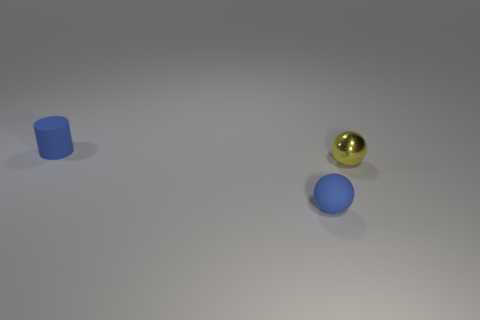Add 1 spheres. How many objects exist? 4 Subtract all spheres. How many objects are left? 1 Add 2 blue matte cylinders. How many blue matte cylinders are left? 3 Add 1 small blue balls. How many small blue balls exist? 2 Subtract 0 yellow cubes. How many objects are left? 3 Subtract all gray spheres. Subtract all yellow cubes. How many spheres are left? 2 Subtract all tiny cyan matte cylinders. Subtract all tiny yellow metal spheres. How many objects are left? 2 